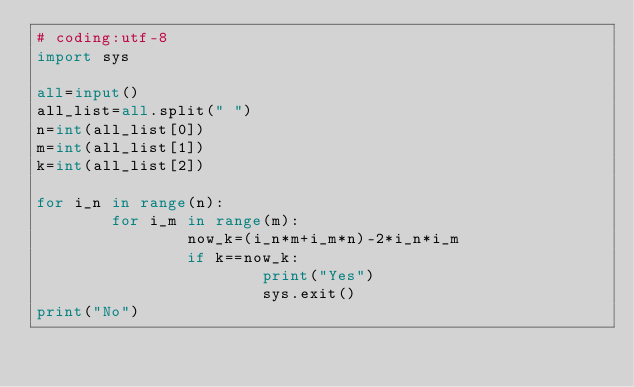<code> <loc_0><loc_0><loc_500><loc_500><_Python_># coding:utf-8
import sys

all=input()
all_list=all.split(" ")
n=int(all_list[0])
m=int(all_list[1])
k=int(all_list[2])

for i_n in range(n):
        for i_m in range(m):
                now_k=(i_n*m+i_m*n)-2*i_n*i_m
                if k==now_k:
                        print("Yes")
                        sys.exit()
print("No")
</code> 